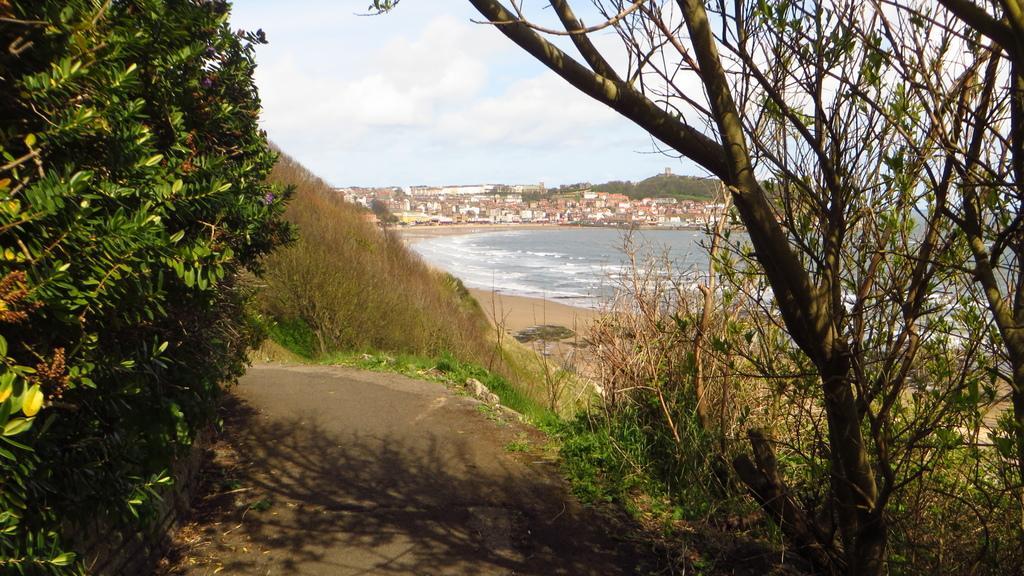Can you describe this image briefly? This picture is clicked outside the city. On the left we can see the tree. In the center there is a green grass and a water body and there are some plants. In the background we can see the sky, buildings and trees. 